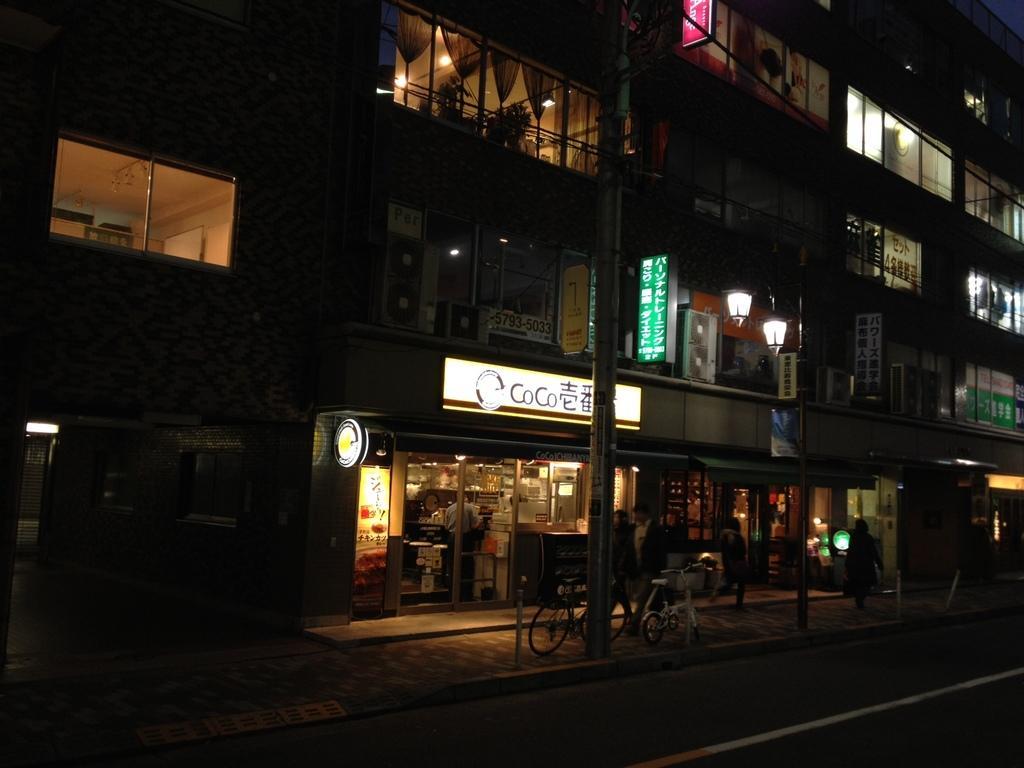How would you summarize this image in a sentence or two? This picture is clicked outside the city. At the bottom of the picture, we see the road and cycles are parked. Beside that, we see a pole. There are buildings in the background. We see board in white and green color with some text written on it. This picture is clicked in the dark. 